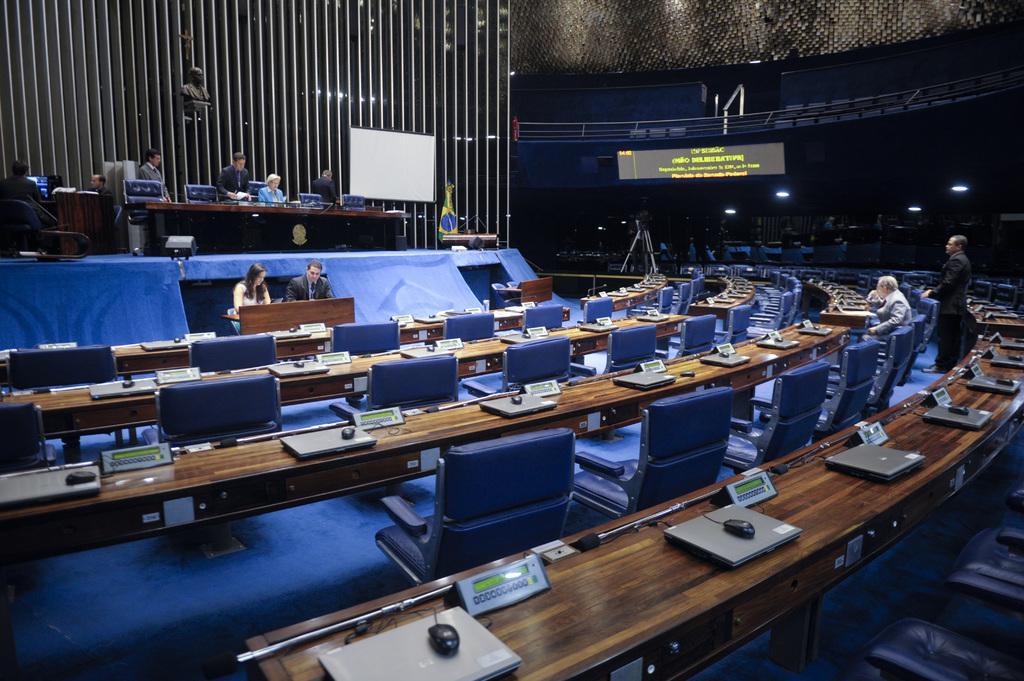Describe this image in one or two sentences. In this image we can see persons, tables, laptops, mouses and chairs and some persons are working on the laptops and at the back there is a projector and at the right side we can see a screen which displays by something. 